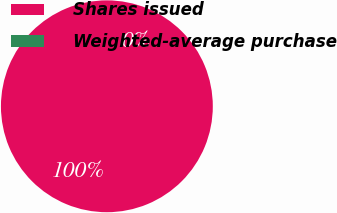Convert chart. <chart><loc_0><loc_0><loc_500><loc_500><pie_chart><fcel>Shares issued<fcel>Weighted-average purchase<nl><fcel>100.0%<fcel>0.0%<nl></chart> 